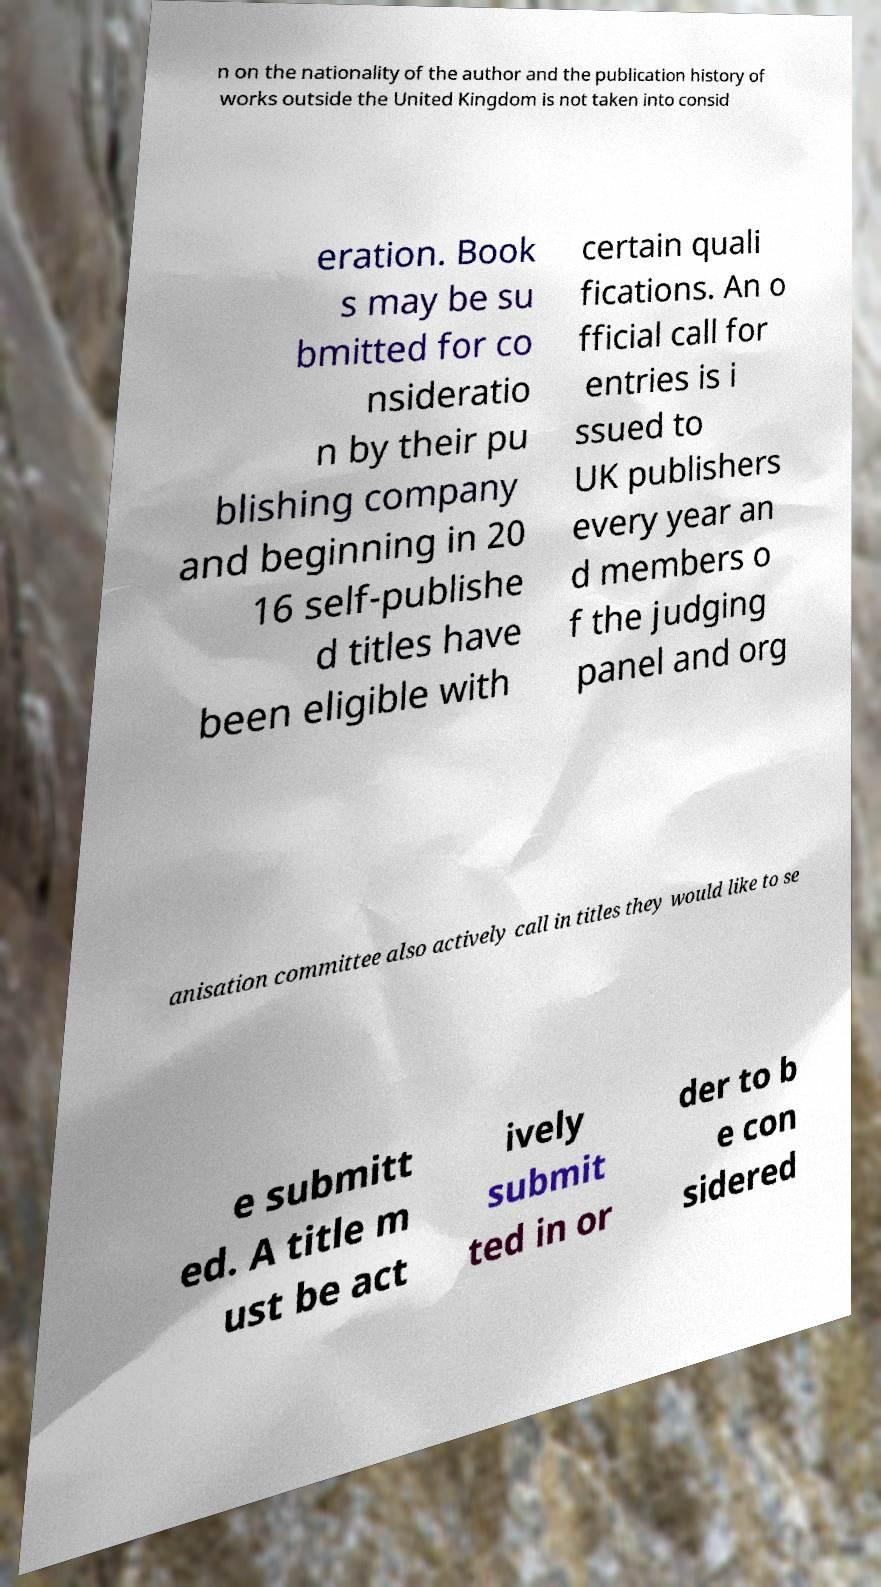Can you accurately transcribe the text from the provided image for me? n on the nationality of the author and the publication history of works outside the United Kingdom is not taken into consid eration. Book s may be su bmitted for co nsideratio n by their pu blishing company and beginning in 20 16 self-publishe d titles have been eligible with certain quali fications. An o fficial call for entries is i ssued to UK publishers every year an d members o f the judging panel and org anisation committee also actively call in titles they would like to se e submitt ed. A title m ust be act ively submit ted in or der to b e con sidered 